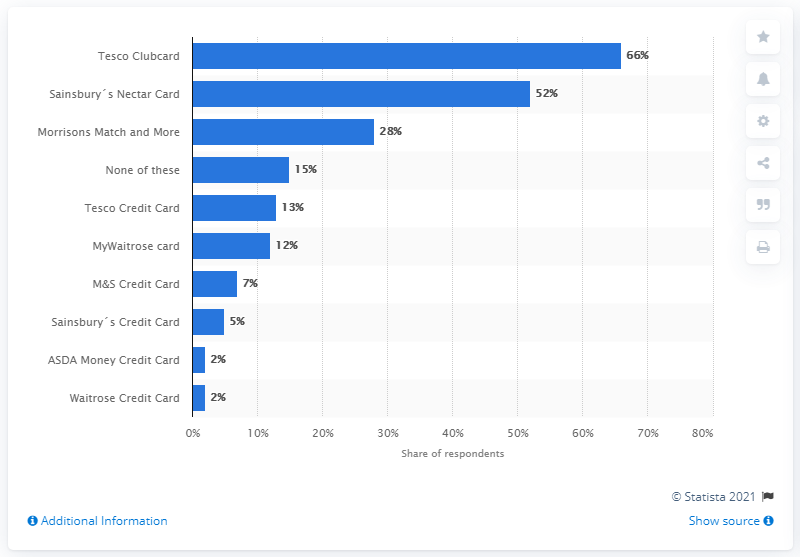Draw attention to some important aspects in this diagram. Tesco Clubcard is the most widely held supermarket loyalty card. According to a survey, 52% of shoppers hold a Sainsbury's Nectar Card. 